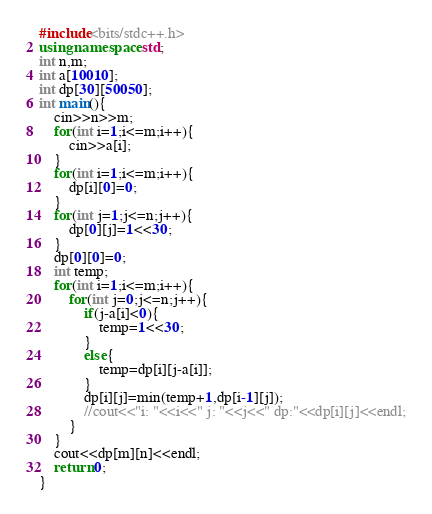Convert code to text. <code><loc_0><loc_0><loc_500><loc_500><_C++_>#include<bits/stdc++.h>
using namespace std;
int n,m;
int a[10010];
int dp[30][50050];
int main(){
	cin>>n>>m;
	for(int i=1;i<=m;i++){
		cin>>a[i];
	}
	for(int i=1;i<=m;i++){
		dp[i][0]=0;
	}
	for(int j=1;j<=n;j++){
		dp[0][j]=1<<30;
	}
	dp[0][0]=0;
	int temp;
	for(int i=1;i<=m;i++){
		for(int j=0;j<=n;j++){
			if(j-a[i]<0){
				temp=1<<30;
			}
			else{
				temp=dp[i][j-a[i]];
			}
			dp[i][j]=min(temp+1,dp[i-1][j]);
			//cout<<"i: "<<i<<" j: "<<j<<" dp:"<<dp[i][j]<<endl;
		}
	}
	cout<<dp[m][n]<<endl;
	return 0;
} 

</code> 